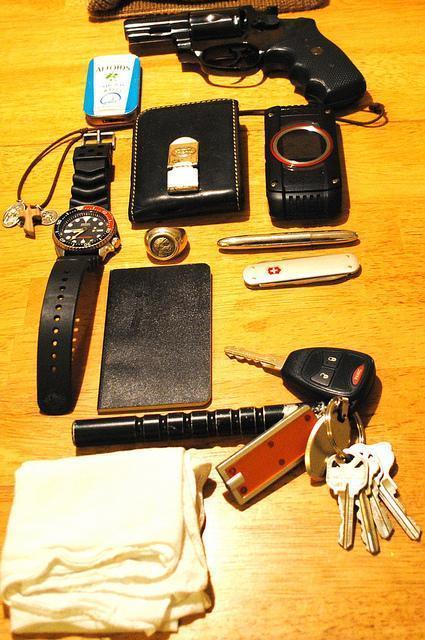How many items?
Give a very brief answer. 13. How many sets of keys are visible?
Give a very brief answer. 1. How many cell phones can be seen?
Give a very brief answer. 2. 